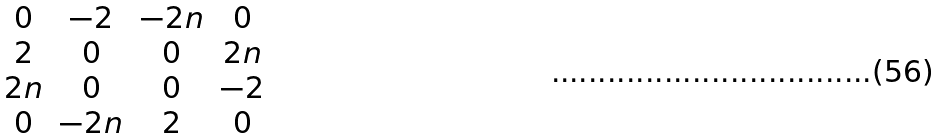<formula> <loc_0><loc_0><loc_500><loc_500>\begin{matrix} 0 & - 2 & - 2 n & 0 \\ 2 & 0 & 0 & 2 n \\ 2 n & 0 & 0 & - 2 \\ 0 & - 2 n & 2 & 0 \end{matrix}</formula> 